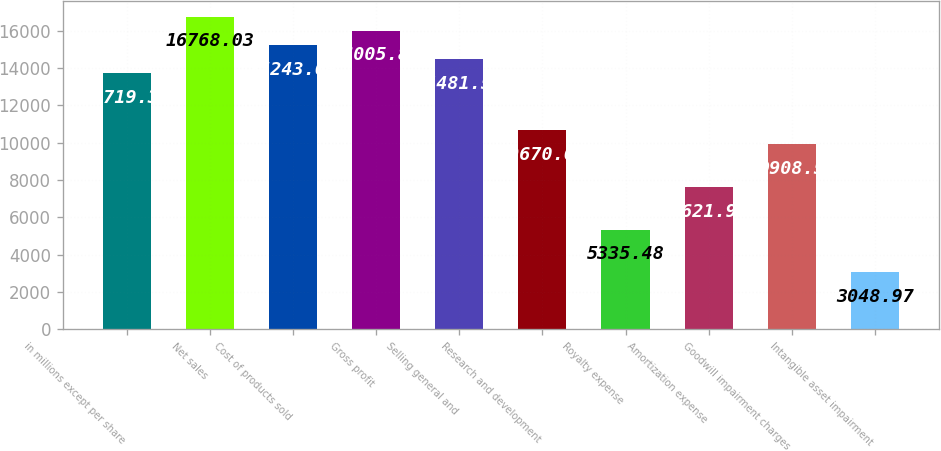Convert chart. <chart><loc_0><loc_0><loc_500><loc_500><bar_chart><fcel>in millions except per share<fcel>Net sales<fcel>Cost of products sold<fcel>Gross profit<fcel>Selling general and<fcel>Research and development<fcel>Royalty expense<fcel>Amortization expense<fcel>Goodwill impairment charges<fcel>Intangible asset impairment<nl><fcel>13719.4<fcel>16768<fcel>15243.7<fcel>16005.9<fcel>14481.5<fcel>10670.7<fcel>5335.48<fcel>7621.99<fcel>9908.5<fcel>3048.97<nl></chart> 